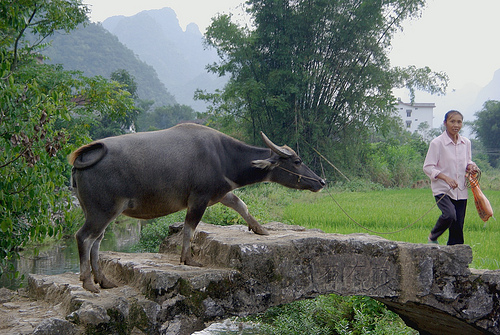<image>
Is there a cow above the bridge? No. The cow is not positioned above the bridge. The vertical arrangement shows a different relationship. 